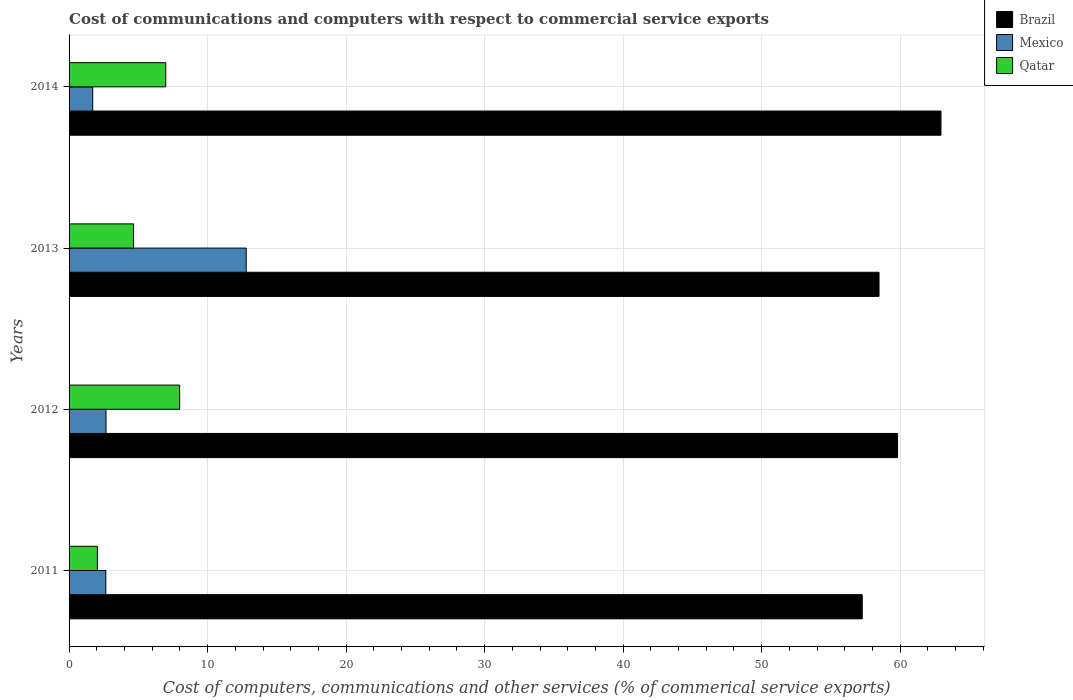How many different coloured bars are there?
Your response must be concise. 3. Are the number of bars per tick equal to the number of legend labels?
Provide a short and direct response. Yes. How many bars are there on the 1st tick from the bottom?
Give a very brief answer. 3. What is the label of the 3rd group of bars from the top?
Offer a very short reply. 2012. In how many cases, is the number of bars for a given year not equal to the number of legend labels?
Give a very brief answer. 0. What is the cost of communications and computers in Qatar in 2014?
Provide a succinct answer. 6.98. Across all years, what is the maximum cost of communications and computers in Mexico?
Provide a succinct answer. 12.79. Across all years, what is the minimum cost of communications and computers in Brazil?
Your answer should be very brief. 57.26. In which year was the cost of communications and computers in Mexico maximum?
Make the answer very short. 2013. In which year was the cost of communications and computers in Mexico minimum?
Make the answer very short. 2014. What is the total cost of communications and computers in Qatar in the graph?
Provide a succinct answer. 21.66. What is the difference between the cost of communications and computers in Mexico in 2013 and that in 2014?
Provide a succinct answer. 11.08. What is the difference between the cost of communications and computers in Qatar in 2011 and the cost of communications and computers in Brazil in 2012?
Keep it short and to the point. -57.77. What is the average cost of communications and computers in Mexico per year?
Your answer should be very brief. 4.95. In the year 2012, what is the difference between the cost of communications and computers in Mexico and cost of communications and computers in Qatar?
Provide a short and direct response. -5.32. What is the ratio of the cost of communications and computers in Brazil in 2012 to that in 2013?
Make the answer very short. 1.02. Is the difference between the cost of communications and computers in Mexico in 2012 and 2014 greater than the difference between the cost of communications and computers in Qatar in 2012 and 2014?
Offer a very short reply. No. What is the difference between the highest and the second highest cost of communications and computers in Mexico?
Keep it short and to the point. 10.12. What is the difference between the highest and the lowest cost of communications and computers in Brazil?
Provide a succinct answer. 5.69. Is the sum of the cost of communications and computers in Mexico in 2012 and 2013 greater than the maximum cost of communications and computers in Qatar across all years?
Offer a very short reply. Yes. What does the 1st bar from the bottom in 2014 represents?
Ensure brevity in your answer.  Brazil. How many bars are there?
Give a very brief answer. 12. Are all the bars in the graph horizontal?
Give a very brief answer. Yes. What is the difference between two consecutive major ticks on the X-axis?
Your answer should be very brief. 10. Are the values on the major ticks of X-axis written in scientific E-notation?
Your answer should be very brief. No. Does the graph contain any zero values?
Provide a succinct answer. No. Does the graph contain grids?
Your answer should be compact. Yes. How many legend labels are there?
Provide a short and direct response. 3. What is the title of the graph?
Keep it short and to the point. Cost of communications and computers with respect to commercial service exports. Does "Luxembourg" appear as one of the legend labels in the graph?
Make the answer very short. No. What is the label or title of the X-axis?
Provide a succinct answer. Cost of computers, communications and other services (% of commerical service exports). What is the label or title of the Y-axis?
Provide a succinct answer. Years. What is the Cost of computers, communications and other services (% of commerical service exports) in Brazil in 2011?
Ensure brevity in your answer.  57.26. What is the Cost of computers, communications and other services (% of commerical service exports) in Mexico in 2011?
Your answer should be compact. 2.65. What is the Cost of computers, communications and other services (% of commerical service exports) of Qatar in 2011?
Provide a short and direct response. 2.04. What is the Cost of computers, communications and other services (% of commerical service exports) in Brazil in 2012?
Make the answer very short. 59.81. What is the Cost of computers, communications and other services (% of commerical service exports) of Mexico in 2012?
Ensure brevity in your answer.  2.67. What is the Cost of computers, communications and other services (% of commerical service exports) of Qatar in 2012?
Give a very brief answer. 7.98. What is the Cost of computers, communications and other services (% of commerical service exports) in Brazil in 2013?
Provide a succinct answer. 58.47. What is the Cost of computers, communications and other services (% of commerical service exports) in Mexico in 2013?
Provide a succinct answer. 12.79. What is the Cost of computers, communications and other services (% of commerical service exports) in Qatar in 2013?
Offer a very short reply. 4.66. What is the Cost of computers, communications and other services (% of commerical service exports) of Brazil in 2014?
Make the answer very short. 62.94. What is the Cost of computers, communications and other services (% of commerical service exports) of Mexico in 2014?
Offer a very short reply. 1.71. What is the Cost of computers, communications and other services (% of commerical service exports) of Qatar in 2014?
Your answer should be very brief. 6.98. Across all years, what is the maximum Cost of computers, communications and other services (% of commerical service exports) of Brazil?
Ensure brevity in your answer.  62.94. Across all years, what is the maximum Cost of computers, communications and other services (% of commerical service exports) of Mexico?
Your response must be concise. 12.79. Across all years, what is the maximum Cost of computers, communications and other services (% of commerical service exports) in Qatar?
Provide a succinct answer. 7.98. Across all years, what is the minimum Cost of computers, communications and other services (% of commerical service exports) of Brazil?
Keep it short and to the point. 57.26. Across all years, what is the minimum Cost of computers, communications and other services (% of commerical service exports) of Mexico?
Make the answer very short. 1.71. Across all years, what is the minimum Cost of computers, communications and other services (% of commerical service exports) in Qatar?
Your answer should be compact. 2.04. What is the total Cost of computers, communications and other services (% of commerical service exports) of Brazil in the graph?
Provide a succinct answer. 238.48. What is the total Cost of computers, communications and other services (% of commerical service exports) of Mexico in the graph?
Your answer should be compact. 19.81. What is the total Cost of computers, communications and other services (% of commerical service exports) of Qatar in the graph?
Your answer should be compact. 21.66. What is the difference between the Cost of computers, communications and other services (% of commerical service exports) in Brazil in 2011 and that in 2012?
Provide a short and direct response. -2.55. What is the difference between the Cost of computers, communications and other services (% of commerical service exports) of Mexico in 2011 and that in 2012?
Your answer should be compact. -0.01. What is the difference between the Cost of computers, communications and other services (% of commerical service exports) in Qatar in 2011 and that in 2012?
Ensure brevity in your answer.  -5.94. What is the difference between the Cost of computers, communications and other services (% of commerical service exports) in Brazil in 2011 and that in 2013?
Provide a short and direct response. -1.21. What is the difference between the Cost of computers, communications and other services (% of commerical service exports) of Mexico in 2011 and that in 2013?
Provide a short and direct response. -10.13. What is the difference between the Cost of computers, communications and other services (% of commerical service exports) in Qatar in 2011 and that in 2013?
Offer a very short reply. -2.61. What is the difference between the Cost of computers, communications and other services (% of commerical service exports) of Brazil in 2011 and that in 2014?
Your answer should be compact. -5.69. What is the difference between the Cost of computers, communications and other services (% of commerical service exports) in Mexico in 2011 and that in 2014?
Give a very brief answer. 0.95. What is the difference between the Cost of computers, communications and other services (% of commerical service exports) in Qatar in 2011 and that in 2014?
Your answer should be compact. -4.94. What is the difference between the Cost of computers, communications and other services (% of commerical service exports) of Brazil in 2012 and that in 2013?
Provide a short and direct response. 1.34. What is the difference between the Cost of computers, communications and other services (% of commerical service exports) in Mexico in 2012 and that in 2013?
Provide a short and direct response. -10.12. What is the difference between the Cost of computers, communications and other services (% of commerical service exports) of Qatar in 2012 and that in 2013?
Make the answer very short. 3.33. What is the difference between the Cost of computers, communications and other services (% of commerical service exports) in Brazil in 2012 and that in 2014?
Ensure brevity in your answer.  -3.13. What is the difference between the Cost of computers, communications and other services (% of commerical service exports) in Mexico in 2012 and that in 2014?
Provide a short and direct response. 0.96. What is the difference between the Cost of computers, communications and other services (% of commerical service exports) of Qatar in 2012 and that in 2014?
Make the answer very short. 1. What is the difference between the Cost of computers, communications and other services (% of commerical service exports) of Brazil in 2013 and that in 2014?
Your response must be concise. -4.47. What is the difference between the Cost of computers, communications and other services (% of commerical service exports) in Mexico in 2013 and that in 2014?
Offer a very short reply. 11.08. What is the difference between the Cost of computers, communications and other services (% of commerical service exports) in Qatar in 2013 and that in 2014?
Your answer should be compact. -2.32. What is the difference between the Cost of computers, communications and other services (% of commerical service exports) in Brazil in 2011 and the Cost of computers, communications and other services (% of commerical service exports) in Mexico in 2012?
Offer a very short reply. 54.59. What is the difference between the Cost of computers, communications and other services (% of commerical service exports) in Brazil in 2011 and the Cost of computers, communications and other services (% of commerical service exports) in Qatar in 2012?
Give a very brief answer. 49.28. What is the difference between the Cost of computers, communications and other services (% of commerical service exports) in Mexico in 2011 and the Cost of computers, communications and other services (% of commerical service exports) in Qatar in 2012?
Your answer should be very brief. -5.33. What is the difference between the Cost of computers, communications and other services (% of commerical service exports) of Brazil in 2011 and the Cost of computers, communications and other services (% of commerical service exports) of Mexico in 2013?
Make the answer very short. 44.47. What is the difference between the Cost of computers, communications and other services (% of commerical service exports) of Brazil in 2011 and the Cost of computers, communications and other services (% of commerical service exports) of Qatar in 2013?
Give a very brief answer. 52.6. What is the difference between the Cost of computers, communications and other services (% of commerical service exports) in Mexico in 2011 and the Cost of computers, communications and other services (% of commerical service exports) in Qatar in 2013?
Provide a succinct answer. -2. What is the difference between the Cost of computers, communications and other services (% of commerical service exports) of Brazil in 2011 and the Cost of computers, communications and other services (% of commerical service exports) of Mexico in 2014?
Your answer should be compact. 55.55. What is the difference between the Cost of computers, communications and other services (% of commerical service exports) in Brazil in 2011 and the Cost of computers, communications and other services (% of commerical service exports) in Qatar in 2014?
Offer a terse response. 50.28. What is the difference between the Cost of computers, communications and other services (% of commerical service exports) in Mexico in 2011 and the Cost of computers, communications and other services (% of commerical service exports) in Qatar in 2014?
Offer a terse response. -4.33. What is the difference between the Cost of computers, communications and other services (% of commerical service exports) in Brazil in 2012 and the Cost of computers, communications and other services (% of commerical service exports) in Mexico in 2013?
Ensure brevity in your answer.  47.02. What is the difference between the Cost of computers, communications and other services (% of commerical service exports) of Brazil in 2012 and the Cost of computers, communications and other services (% of commerical service exports) of Qatar in 2013?
Provide a short and direct response. 55.15. What is the difference between the Cost of computers, communications and other services (% of commerical service exports) in Mexico in 2012 and the Cost of computers, communications and other services (% of commerical service exports) in Qatar in 2013?
Provide a succinct answer. -1.99. What is the difference between the Cost of computers, communications and other services (% of commerical service exports) in Brazil in 2012 and the Cost of computers, communications and other services (% of commerical service exports) in Mexico in 2014?
Offer a very short reply. 58.1. What is the difference between the Cost of computers, communications and other services (% of commerical service exports) in Brazil in 2012 and the Cost of computers, communications and other services (% of commerical service exports) in Qatar in 2014?
Your answer should be very brief. 52.83. What is the difference between the Cost of computers, communications and other services (% of commerical service exports) of Mexico in 2012 and the Cost of computers, communications and other services (% of commerical service exports) of Qatar in 2014?
Ensure brevity in your answer.  -4.31. What is the difference between the Cost of computers, communications and other services (% of commerical service exports) in Brazil in 2013 and the Cost of computers, communications and other services (% of commerical service exports) in Mexico in 2014?
Keep it short and to the point. 56.76. What is the difference between the Cost of computers, communications and other services (% of commerical service exports) of Brazil in 2013 and the Cost of computers, communications and other services (% of commerical service exports) of Qatar in 2014?
Make the answer very short. 51.49. What is the difference between the Cost of computers, communications and other services (% of commerical service exports) in Mexico in 2013 and the Cost of computers, communications and other services (% of commerical service exports) in Qatar in 2014?
Offer a very short reply. 5.81. What is the average Cost of computers, communications and other services (% of commerical service exports) of Brazil per year?
Your answer should be very brief. 59.62. What is the average Cost of computers, communications and other services (% of commerical service exports) in Mexico per year?
Keep it short and to the point. 4.95. What is the average Cost of computers, communications and other services (% of commerical service exports) in Qatar per year?
Offer a very short reply. 5.42. In the year 2011, what is the difference between the Cost of computers, communications and other services (% of commerical service exports) in Brazil and Cost of computers, communications and other services (% of commerical service exports) in Mexico?
Give a very brief answer. 54.61. In the year 2011, what is the difference between the Cost of computers, communications and other services (% of commerical service exports) in Brazil and Cost of computers, communications and other services (% of commerical service exports) in Qatar?
Make the answer very short. 55.21. In the year 2011, what is the difference between the Cost of computers, communications and other services (% of commerical service exports) of Mexico and Cost of computers, communications and other services (% of commerical service exports) of Qatar?
Ensure brevity in your answer.  0.61. In the year 2012, what is the difference between the Cost of computers, communications and other services (% of commerical service exports) in Brazil and Cost of computers, communications and other services (% of commerical service exports) in Mexico?
Ensure brevity in your answer.  57.14. In the year 2012, what is the difference between the Cost of computers, communications and other services (% of commerical service exports) of Brazil and Cost of computers, communications and other services (% of commerical service exports) of Qatar?
Your answer should be compact. 51.83. In the year 2012, what is the difference between the Cost of computers, communications and other services (% of commerical service exports) of Mexico and Cost of computers, communications and other services (% of commerical service exports) of Qatar?
Provide a succinct answer. -5.32. In the year 2013, what is the difference between the Cost of computers, communications and other services (% of commerical service exports) of Brazil and Cost of computers, communications and other services (% of commerical service exports) of Mexico?
Make the answer very short. 45.68. In the year 2013, what is the difference between the Cost of computers, communications and other services (% of commerical service exports) of Brazil and Cost of computers, communications and other services (% of commerical service exports) of Qatar?
Offer a very short reply. 53.81. In the year 2013, what is the difference between the Cost of computers, communications and other services (% of commerical service exports) of Mexico and Cost of computers, communications and other services (% of commerical service exports) of Qatar?
Provide a short and direct response. 8.13. In the year 2014, what is the difference between the Cost of computers, communications and other services (% of commerical service exports) of Brazil and Cost of computers, communications and other services (% of commerical service exports) of Mexico?
Give a very brief answer. 61.24. In the year 2014, what is the difference between the Cost of computers, communications and other services (% of commerical service exports) in Brazil and Cost of computers, communications and other services (% of commerical service exports) in Qatar?
Offer a very short reply. 55.97. In the year 2014, what is the difference between the Cost of computers, communications and other services (% of commerical service exports) of Mexico and Cost of computers, communications and other services (% of commerical service exports) of Qatar?
Your answer should be compact. -5.27. What is the ratio of the Cost of computers, communications and other services (% of commerical service exports) of Brazil in 2011 to that in 2012?
Your answer should be compact. 0.96. What is the ratio of the Cost of computers, communications and other services (% of commerical service exports) in Qatar in 2011 to that in 2012?
Provide a short and direct response. 0.26. What is the ratio of the Cost of computers, communications and other services (% of commerical service exports) of Brazil in 2011 to that in 2013?
Offer a terse response. 0.98. What is the ratio of the Cost of computers, communications and other services (% of commerical service exports) in Mexico in 2011 to that in 2013?
Give a very brief answer. 0.21. What is the ratio of the Cost of computers, communications and other services (% of commerical service exports) in Qatar in 2011 to that in 2013?
Ensure brevity in your answer.  0.44. What is the ratio of the Cost of computers, communications and other services (% of commerical service exports) of Brazil in 2011 to that in 2014?
Provide a succinct answer. 0.91. What is the ratio of the Cost of computers, communications and other services (% of commerical service exports) of Mexico in 2011 to that in 2014?
Offer a very short reply. 1.55. What is the ratio of the Cost of computers, communications and other services (% of commerical service exports) in Qatar in 2011 to that in 2014?
Provide a short and direct response. 0.29. What is the ratio of the Cost of computers, communications and other services (% of commerical service exports) of Brazil in 2012 to that in 2013?
Your answer should be compact. 1.02. What is the ratio of the Cost of computers, communications and other services (% of commerical service exports) of Mexico in 2012 to that in 2013?
Keep it short and to the point. 0.21. What is the ratio of the Cost of computers, communications and other services (% of commerical service exports) of Qatar in 2012 to that in 2013?
Offer a very short reply. 1.71. What is the ratio of the Cost of computers, communications and other services (% of commerical service exports) in Brazil in 2012 to that in 2014?
Provide a succinct answer. 0.95. What is the ratio of the Cost of computers, communications and other services (% of commerical service exports) in Mexico in 2012 to that in 2014?
Your response must be concise. 1.56. What is the ratio of the Cost of computers, communications and other services (% of commerical service exports) of Qatar in 2012 to that in 2014?
Keep it short and to the point. 1.14. What is the ratio of the Cost of computers, communications and other services (% of commerical service exports) of Brazil in 2013 to that in 2014?
Give a very brief answer. 0.93. What is the ratio of the Cost of computers, communications and other services (% of commerical service exports) in Mexico in 2013 to that in 2014?
Your answer should be compact. 7.49. What is the ratio of the Cost of computers, communications and other services (% of commerical service exports) of Qatar in 2013 to that in 2014?
Ensure brevity in your answer.  0.67. What is the difference between the highest and the second highest Cost of computers, communications and other services (% of commerical service exports) of Brazil?
Ensure brevity in your answer.  3.13. What is the difference between the highest and the second highest Cost of computers, communications and other services (% of commerical service exports) of Mexico?
Give a very brief answer. 10.12. What is the difference between the highest and the second highest Cost of computers, communications and other services (% of commerical service exports) in Qatar?
Give a very brief answer. 1. What is the difference between the highest and the lowest Cost of computers, communications and other services (% of commerical service exports) in Brazil?
Your answer should be compact. 5.69. What is the difference between the highest and the lowest Cost of computers, communications and other services (% of commerical service exports) of Mexico?
Your answer should be very brief. 11.08. What is the difference between the highest and the lowest Cost of computers, communications and other services (% of commerical service exports) of Qatar?
Make the answer very short. 5.94. 